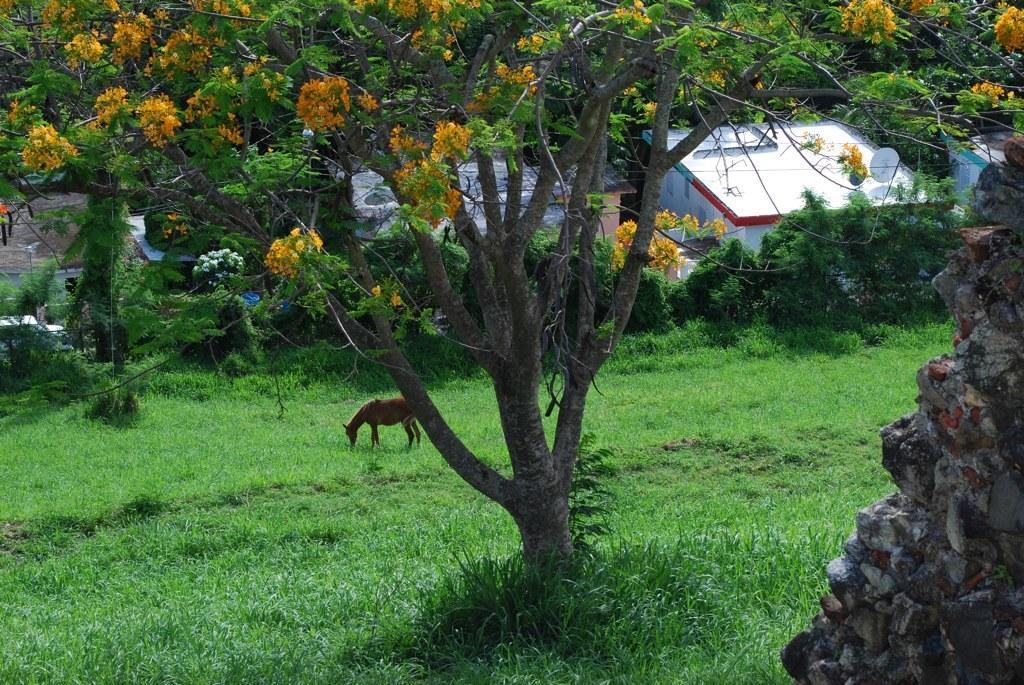Could you give a brief overview of what you see in this image? In this image I can see the grass, the rock wall and a tree to which I can see few flowers which are orange in color. In the background I can see an animal is standing and grazing the grass, few buildings which are white in color and a vehicle. 